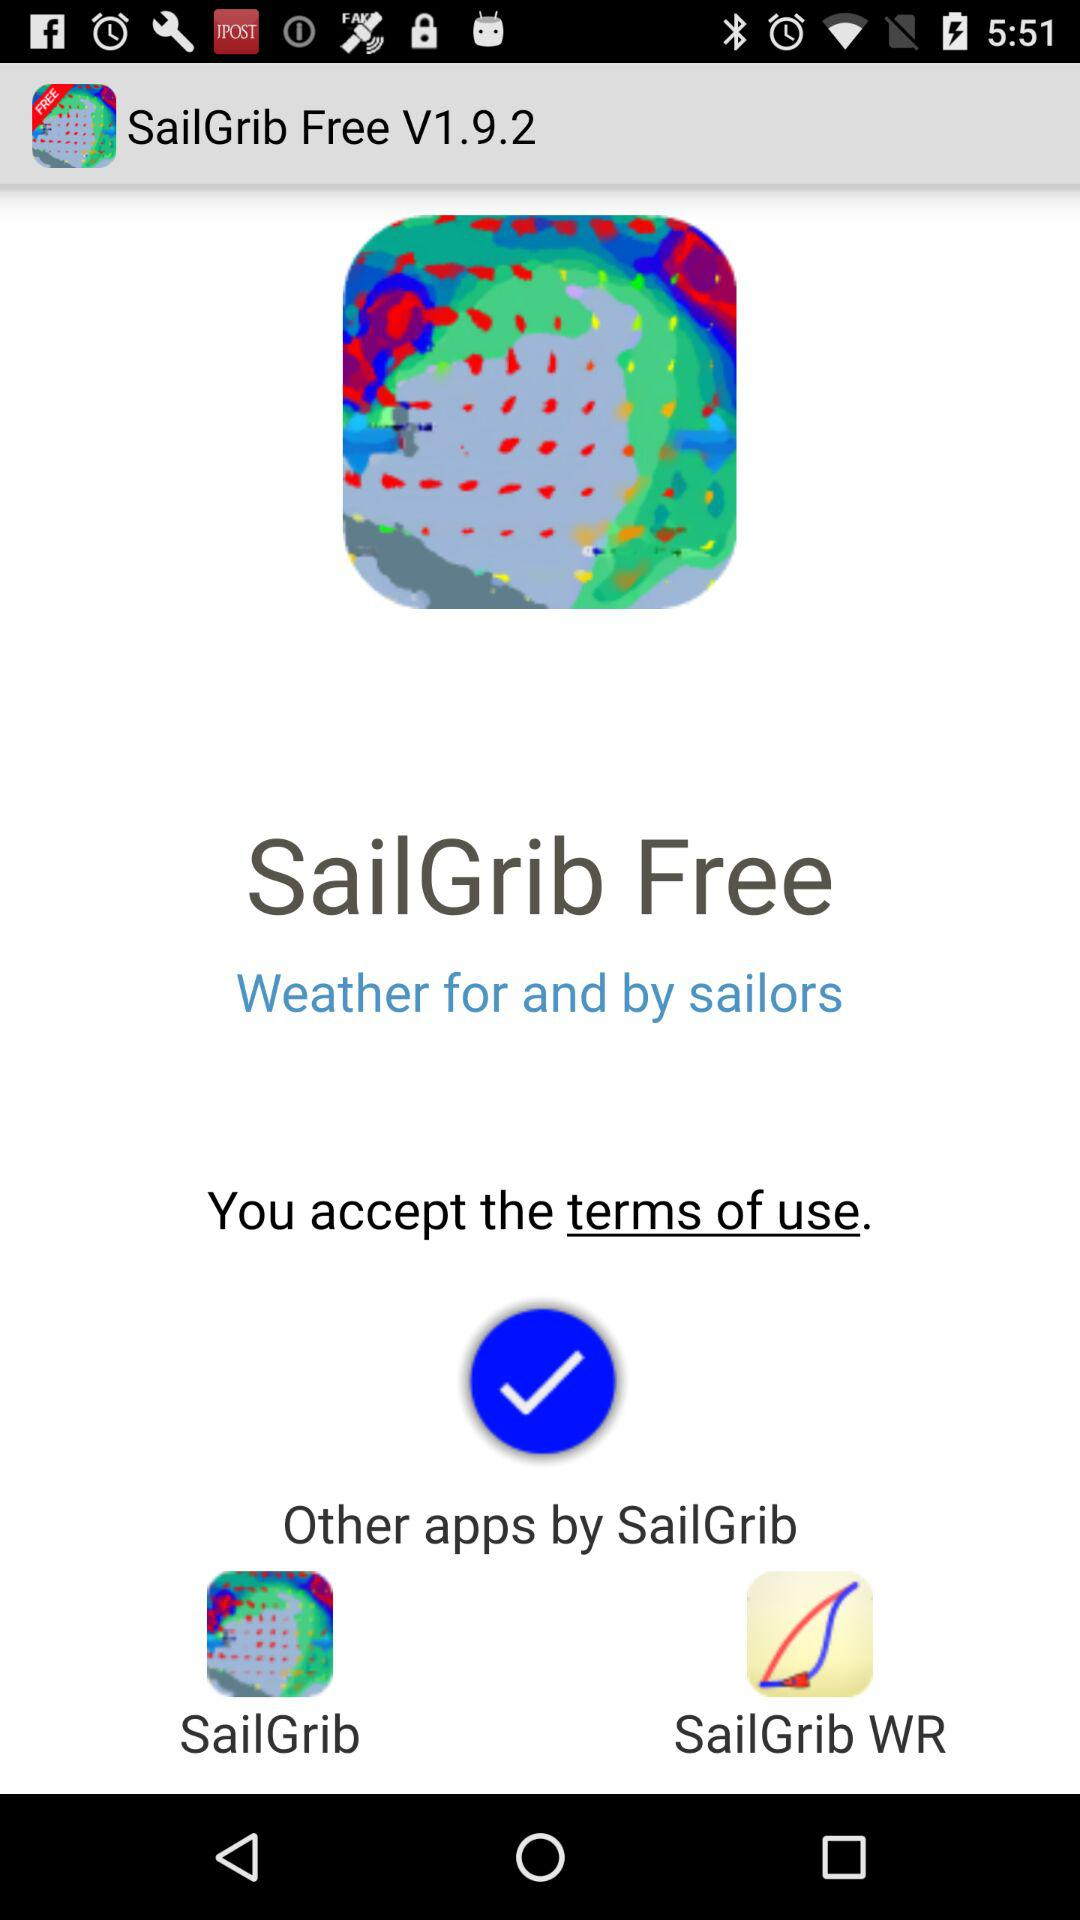What are the available apps? The available apps are "SailGrib Free", "SailGrib" and "SailGrib WR". 